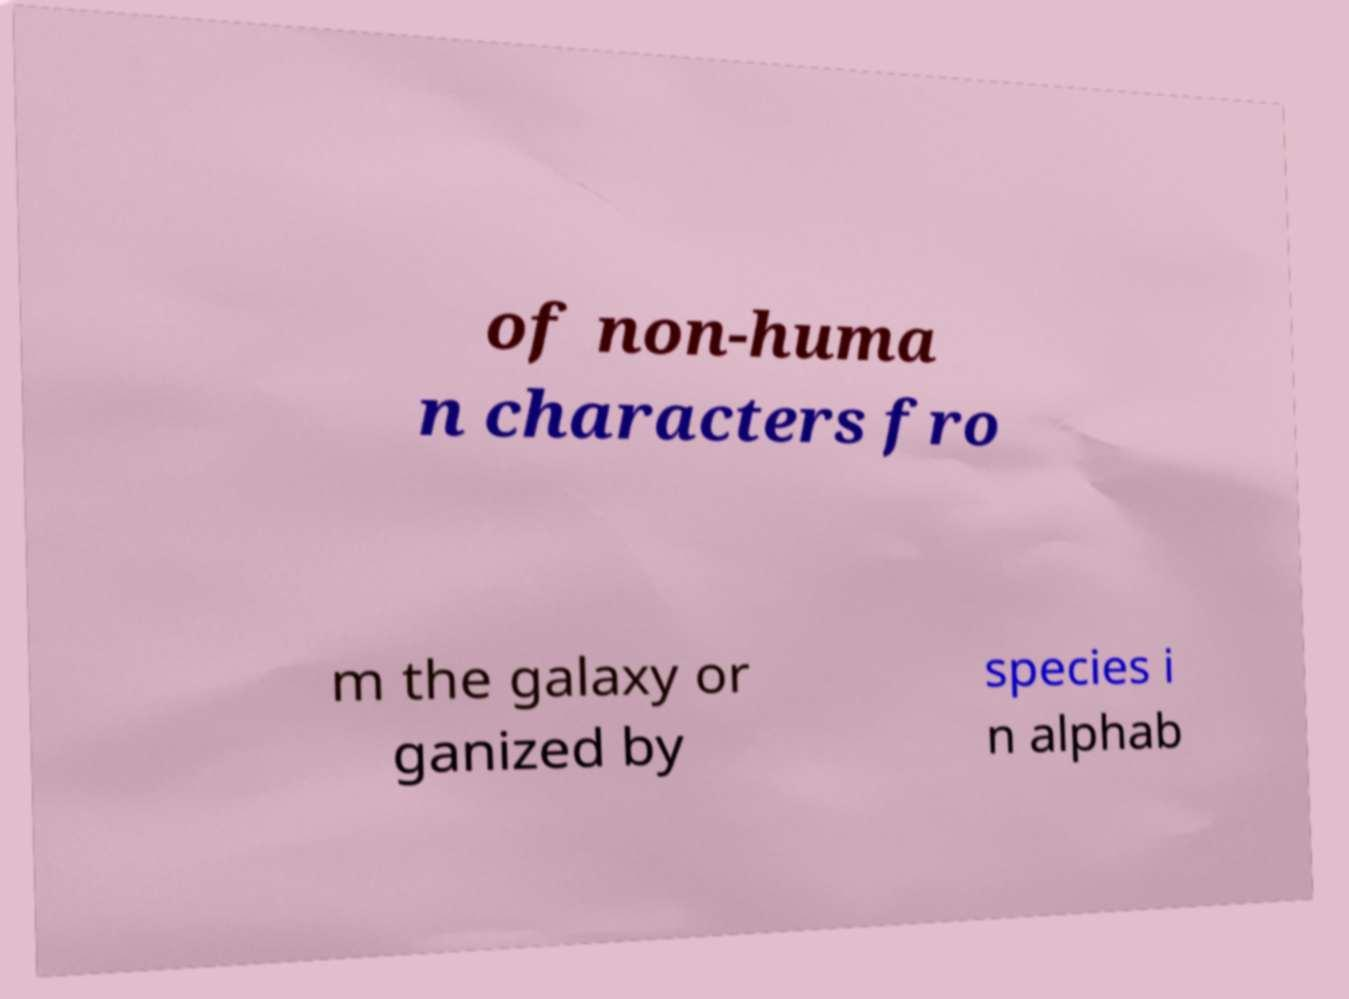Please identify and transcribe the text found in this image. of non-huma n characters fro m the galaxy or ganized by species i n alphab 